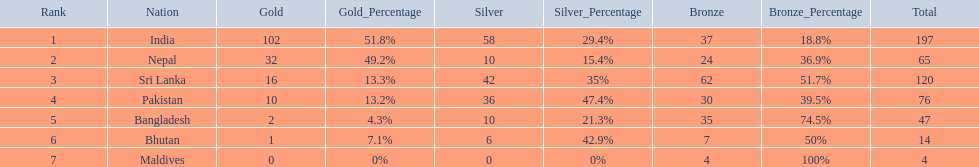What are the totals of medals one in each country? 197, 65, 120, 76, 47, 14, 4. Which of these totals are less than 10? 4. Who won this number of medals? Maldives. 